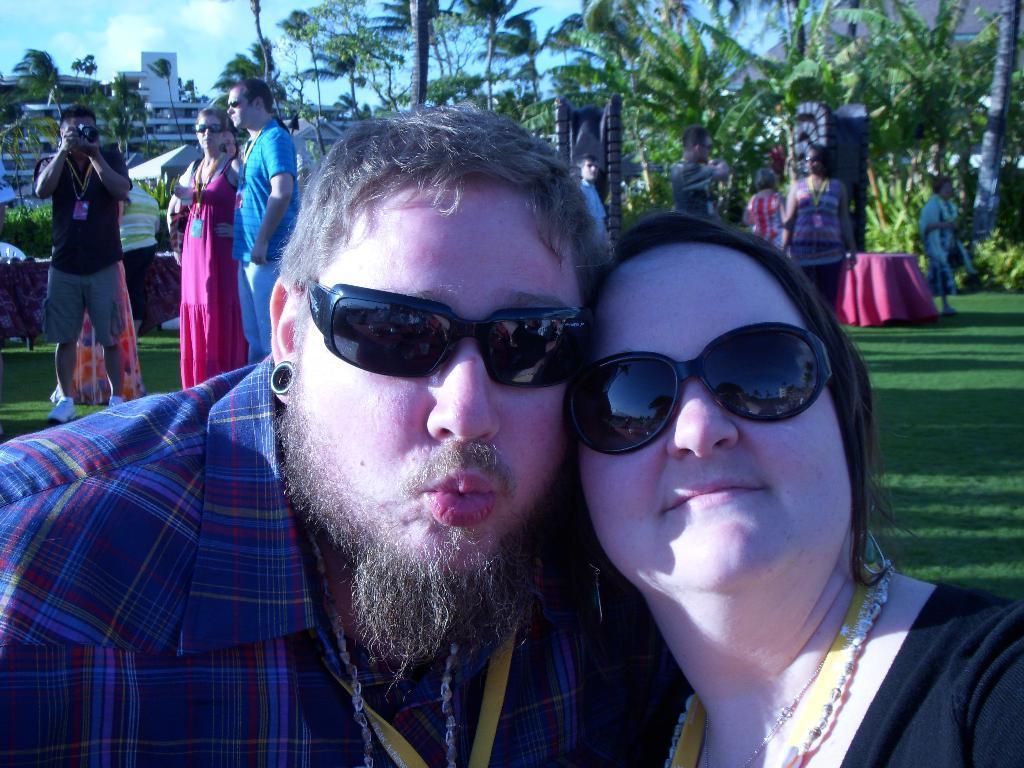Describe this image in one or two sentences. In the foreground of the picture we can see a man and a woman. In the middle of the picture there are trees, people, tables, plants and various objects. At the top it is sky. On the right we can see a building. 